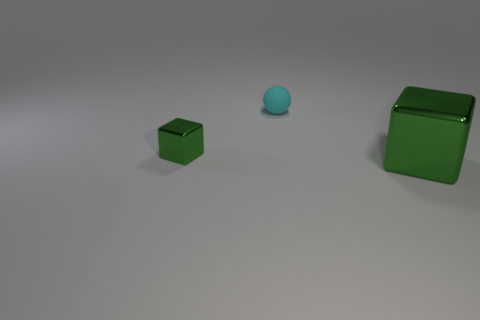Is there any sense of movement in this image or do they appear static? The objects appear static, with no evidence of movement or dynamism; they are arranged still on a plain surface. The absence of trails, motion blur or any dynamic elements supports the impression of a tranquil, unmoving scene. 